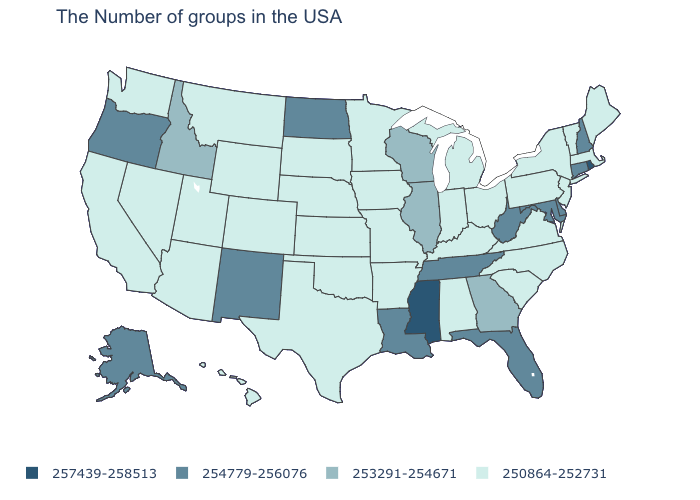Name the states that have a value in the range 253291-254671?
Write a very short answer. Georgia, Wisconsin, Illinois, Idaho. What is the value of Rhode Island?
Answer briefly. 257439-258513. Does Ohio have the lowest value in the MidWest?
Be succinct. Yes. What is the value of Louisiana?
Answer briefly. 254779-256076. Is the legend a continuous bar?
Short answer required. No. Which states have the lowest value in the USA?
Concise answer only. Maine, Massachusetts, Vermont, New York, New Jersey, Pennsylvania, Virginia, North Carolina, South Carolina, Ohio, Michigan, Kentucky, Indiana, Alabama, Missouri, Arkansas, Minnesota, Iowa, Kansas, Nebraska, Oklahoma, Texas, South Dakota, Wyoming, Colorado, Utah, Montana, Arizona, Nevada, California, Washington, Hawaii. Among the states that border Idaho , does Oregon have the highest value?
Answer briefly. Yes. Among the states that border South Dakota , does Minnesota have the highest value?
Keep it brief. No. Among the states that border Tennessee , does Mississippi have the lowest value?
Keep it brief. No. Name the states that have a value in the range 250864-252731?
Write a very short answer. Maine, Massachusetts, Vermont, New York, New Jersey, Pennsylvania, Virginia, North Carolina, South Carolina, Ohio, Michigan, Kentucky, Indiana, Alabama, Missouri, Arkansas, Minnesota, Iowa, Kansas, Nebraska, Oklahoma, Texas, South Dakota, Wyoming, Colorado, Utah, Montana, Arizona, Nevada, California, Washington, Hawaii. Name the states that have a value in the range 253291-254671?
Write a very short answer. Georgia, Wisconsin, Illinois, Idaho. Among the states that border New York , which have the lowest value?
Short answer required. Massachusetts, Vermont, New Jersey, Pennsylvania. What is the value of New Jersey?
Quick response, please. 250864-252731. What is the value of Utah?
Keep it brief. 250864-252731. 